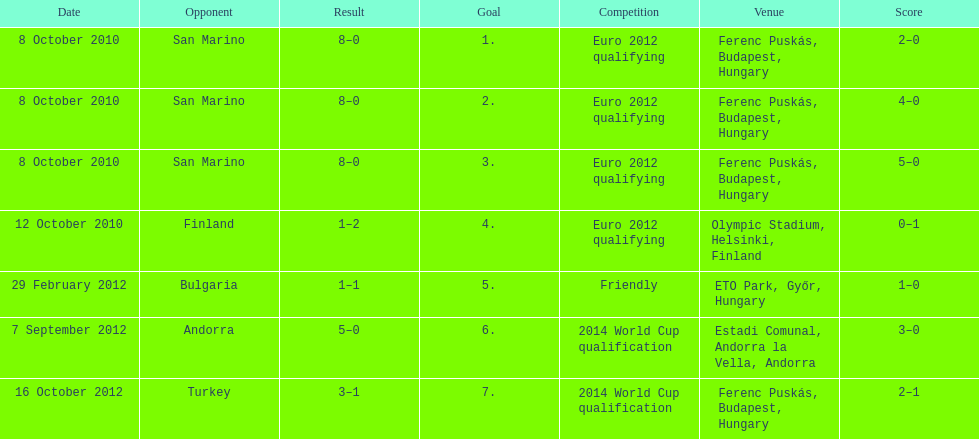In what year did ádám szalai achieve his next international goal post-2010? 2012. 